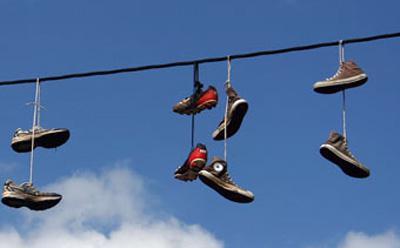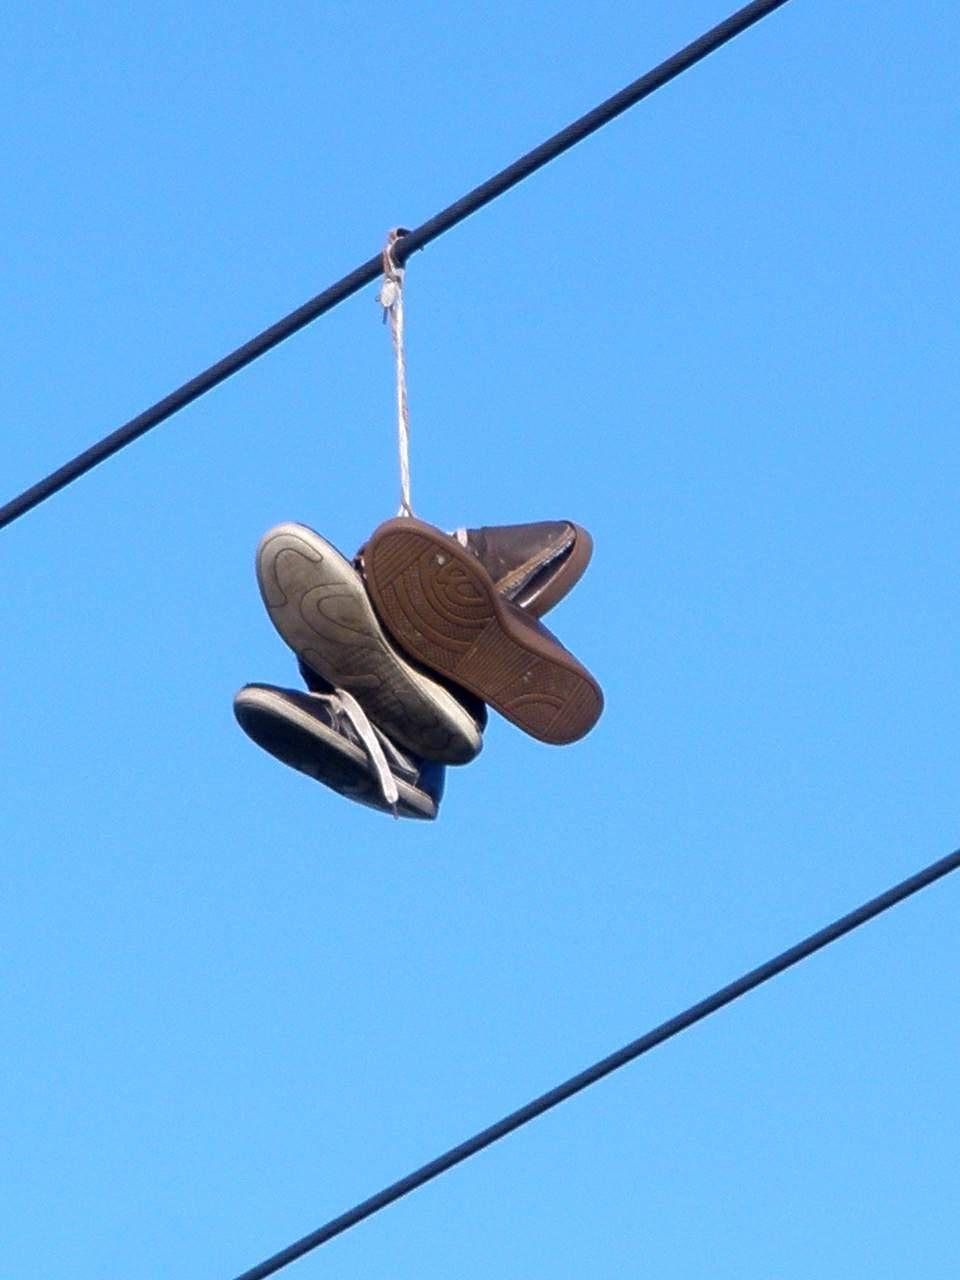The first image is the image on the left, the second image is the image on the right. Given the left and right images, does the statement "There are exactly two shoes hanging on the line in the image on the right" hold true? Answer yes or no. No. The first image is the image on the left, the second image is the image on the right. For the images shown, is this caption "Left image shows just one pair of sneakers dangling from a wire." true? Answer yes or no. No. 